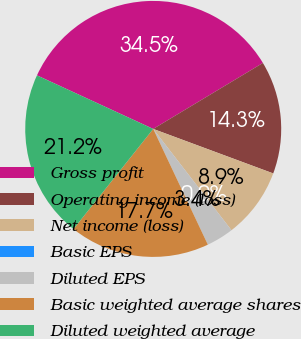Convert chart. <chart><loc_0><loc_0><loc_500><loc_500><pie_chart><fcel>Gross profit<fcel>Operating income (loss)<fcel>Net income (loss)<fcel>Basic EPS<fcel>Diluted EPS<fcel>Basic weighted average shares<fcel>Diluted weighted average<nl><fcel>34.51%<fcel>14.27%<fcel>8.88%<fcel>0.0%<fcel>3.45%<fcel>17.72%<fcel>21.17%<nl></chart> 